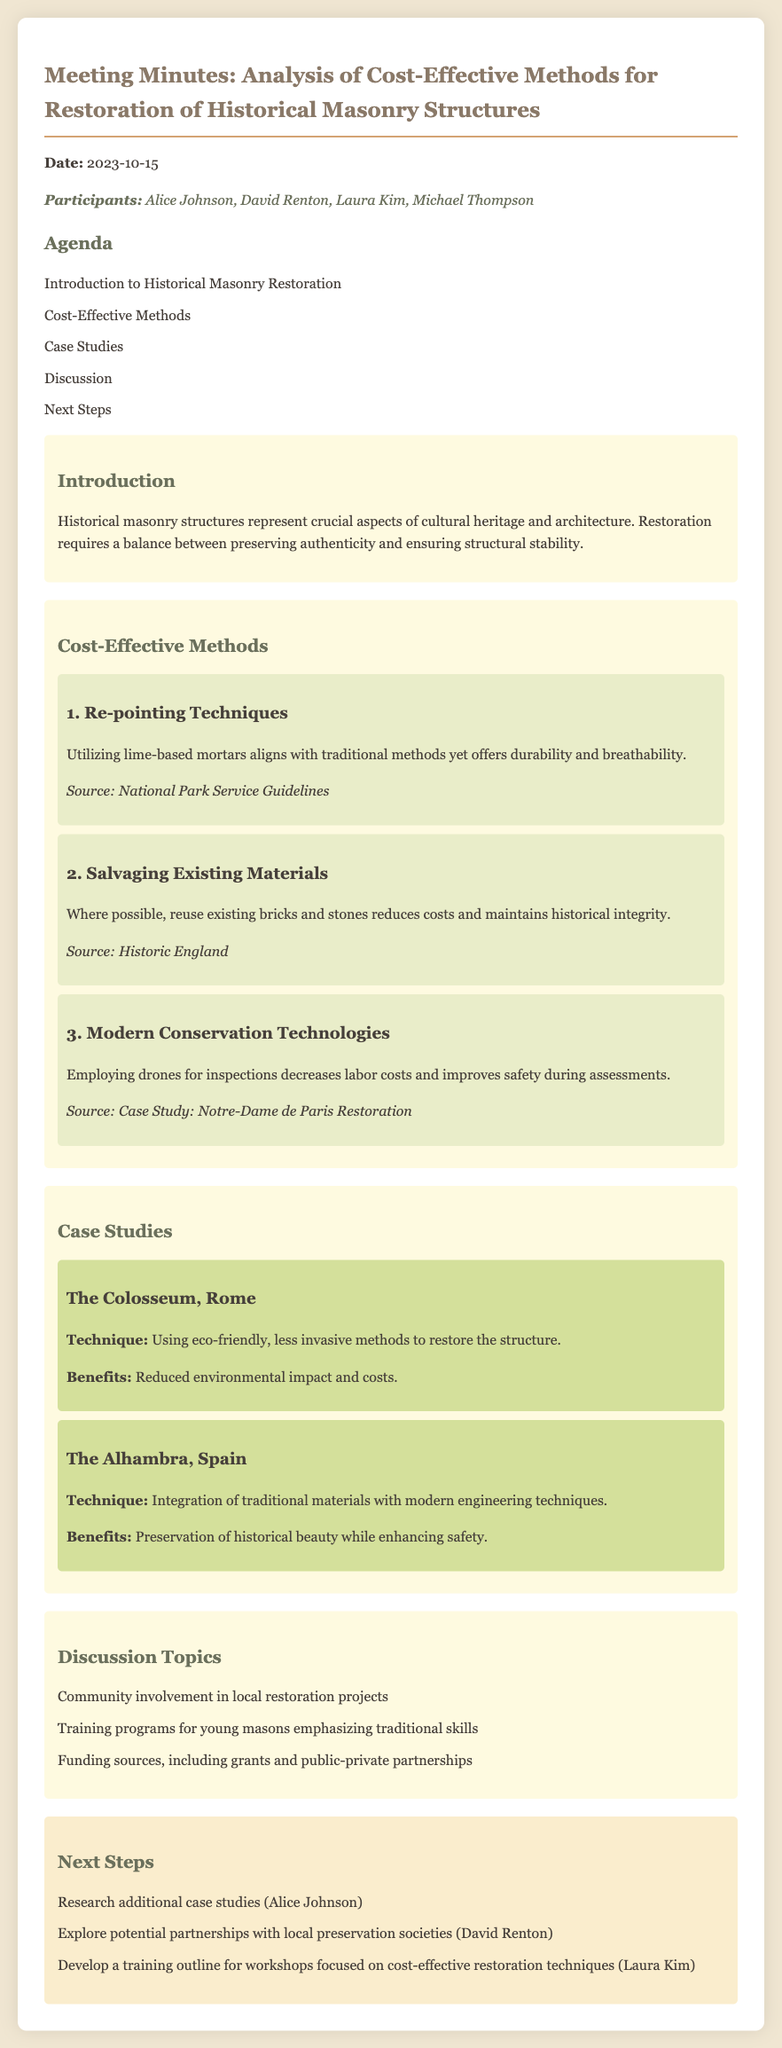What is the meeting date? The date of the meeting is mentioned at the beginning of the minutes.
Answer: 2023-10-15 Who are the participants? The names of the participants are listed immediately under the meeting date.
Answer: Alice Johnson, David Renton, Laura Kim, Michael Thompson What is one cost-effective method mentioned for restoration? The document lists cost-effective methods under a specific section.
Answer: Re-pointing Techniques Which case study involves eco-friendly methods? The document specifies techniques used in case studies, including their focus areas.
Answer: The Colosseum, Rome What is a benefit of integrating traditional materials? The benefits of techniques used in case studies are outlined in the document.
Answer: Preservation of historical beauty while enhancing safety Who is responsible for researching additional case studies? The next steps outline responsibilities assigned to participants after the discussion.
Answer: Alice Johnson What restoration technique was used at Notre-Dame de Paris? The document mentions modern conservation technologies discussed during the meeting.
Answer: Employing drones for inspections What was a topic of discussion during the meeting? There is a list of discussion topics included in the minutes.
Answer: Community involvement in local restoration projects 